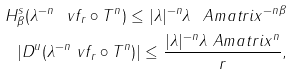Convert formula to latex. <formula><loc_0><loc_0><loc_500><loc_500>H ^ { s } _ { \beta } ( \lambda ^ { - n } \ v f _ { r } \circ T ^ { n } ) \leq | \lambda | ^ { - n } \lambda _ { \ } A m a t r i x ^ { - n \beta } \\ | D ^ { u } ( \lambda ^ { - n } \ v f _ { r } \circ T ^ { n } ) | \leq \frac { | \lambda | ^ { - n } \lambda _ { \ } A m a t r i x ^ { n } } { r } ,</formula> 